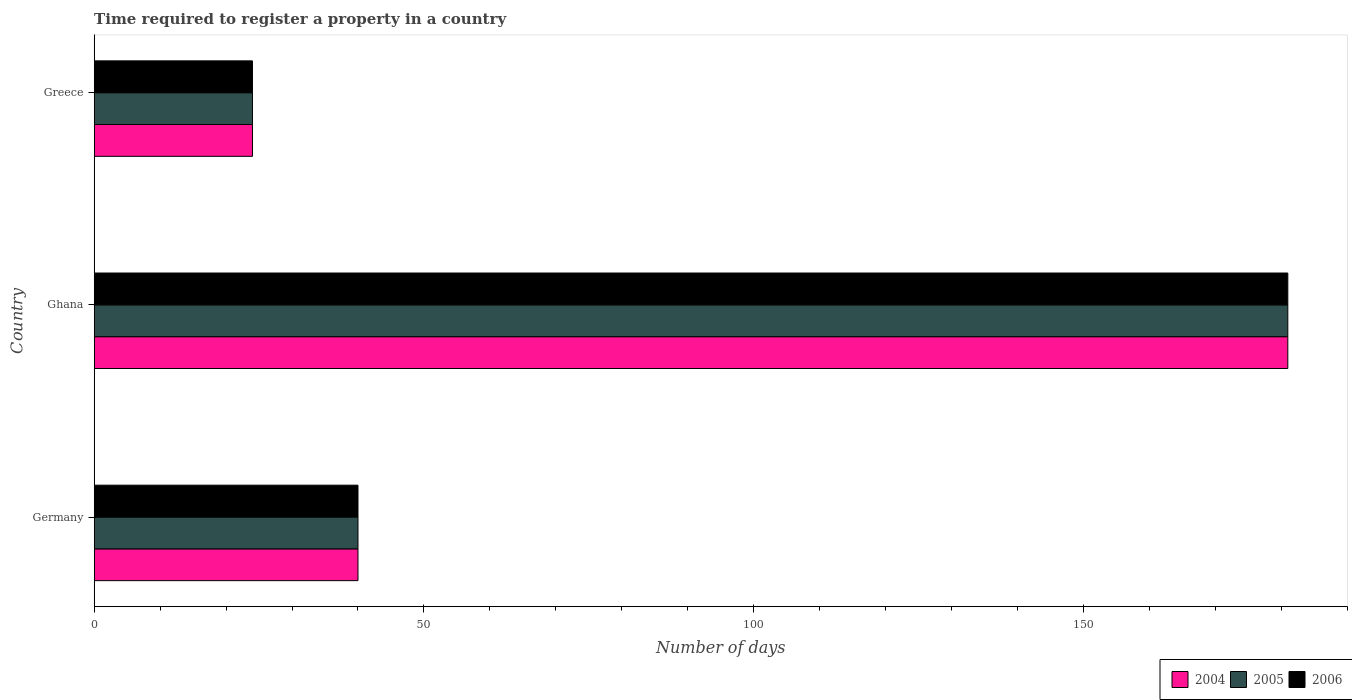How many groups of bars are there?
Your answer should be compact. 3. Are the number of bars per tick equal to the number of legend labels?
Your answer should be very brief. Yes. How many bars are there on the 1st tick from the top?
Your answer should be very brief. 3. What is the label of the 2nd group of bars from the top?
Give a very brief answer. Ghana. In how many cases, is the number of bars for a given country not equal to the number of legend labels?
Give a very brief answer. 0. Across all countries, what is the maximum number of days required to register a property in 2006?
Your answer should be very brief. 181. In which country was the number of days required to register a property in 2006 maximum?
Provide a succinct answer. Ghana. What is the total number of days required to register a property in 2005 in the graph?
Provide a short and direct response. 245. What is the difference between the number of days required to register a property in 2006 in Greece and the number of days required to register a property in 2005 in Ghana?
Keep it short and to the point. -157. What is the average number of days required to register a property in 2006 per country?
Ensure brevity in your answer.  81.67. In how many countries, is the number of days required to register a property in 2006 greater than 110 days?
Your answer should be very brief. 1. What is the ratio of the number of days required to register a property in 2005 in Germany to that in Greece?
Your response must be concise. 1.67. Is the number of days required to register a property in 2004 in Germany less than that in Ghana?
Provide a succinct answer. Yes. Is the difference between the number of days required to register a property in 2005 in Ghana and Greece greater than the difference between the number of days required to register a property in 2004 in Ghana and Greece?
Ensure brevity in your answer.  No. What is the difference between the highest and the second highest number of days required to register a property in 2005?
Provide a short and direct response. 141. What is the difference between the highest and the lowest number of days required to register a property in 2005?
Ensure brevity in your answer.  157. Is the sum of the number of days required to register a property in 2004 in Ghana and Greece greater than the maximum number of days required to register a property in 2005 across all countries?
Keep it short and to the point. Yes. What does the 3rd bar from the top in Germany represents?
Provide a short and direct response. 2004. What does the 1st bar from the bottom in Germany represents?
Make the answer very short. 2004. How many bars are there?
Give a very brief answer. 9. What is the difference between two consecutive major ticks on the X-axis?
Offer a very short reply. 50. Are the values on the major ticks of X-axis written in scientific E-notation?
Offer a terse response. No. Where does the legend appear in the graph?
Give a very brief answer. Bottom right. How are the legend labels stacked?
Your response must be concise. Horizontal. What is the title of the graph?
Provide a succinct answer. Time required to register a property in a country. Does "1986" appear as one of the legend labels in the graph?
Your answer should be compact. No. What is the label or title of the X-axis?
Your response must be concise. Number of days. What is the label or title of the Y-axis?
Offer a very short reply. Country. What is the Number of days in 2004 in Germany?
Make the answer very short. 40. What is the Number of days of 2005 in Germany?
Offer a terse response. 40. What is the Number of days in 2004 in Ghana?
Give a very brief answer. 181. What is the Number of days of 2005 in Ghana?
Your answer should be compact. 181. What is the Number of days of 2006 in Ghana?
Offer a very short reply. 181. What is the Number of days in 2005 in Greece?
Ensure brevity in your answer.  24. What is the Number of days in 2006 in Greece?
Your answer should be compact. 24. Across all countries, what is the maximum Number of days of 2004?
Provide a short and direct response. 181. Across all countries, what is the maximum Number of days in 2005?
Your answer should be very brief. 181. Across all countries, what is the maximum Number of days of 2006?
Offer a very short reply. 181. What is the total Number of days of 2004 in the graph?
Ensure brevity in your answer.  245. What is the total Number of days of 2005 in the graph?
Ensure brevity in your answer.  245. What is the total Number of days in 2006 in the graph?
Your answer should be compact. 245. What is the difference between the Number of days of 2004 in Germany and that in Ghana?
Your answer should be compact. -141. What is the difference between the Number of days of 2005 in Germany and that in Ghana?
Your answer should be compact. -141. What is the difference between the Number of days of 2006 in Germany and that in Ghana?
Your answer should be very brief. -141. What is the difference between the Number of days of 2005 in Germany and that in Greece?
Make the answer very short. 16. What is the difference between the Number of days of 2004 in Ghana and that in Greece?
Offer a very short reply. 157. What is the difference between the Number of days of 2005 in Ghana and that in Greece?
Your response must be concise. 157. What is the difference between the Number of days in 2006 in Ghana and that in Greece?
Provide a succinct answer. 157. What is the difference between the Number of days of 2004 in Germany and the Number of days of 2005 in Ghana?
Give a very brief answer. -141. What is the difference between the Number of days of 2004 in Germany and the Number of days of 2006 in Ghana?
Ensure brevity in your answer.  -141. What is the difference between the Number of days of 2005 in Germany and the Number of days of 2006 in Ghana?
Give a very brief answer. -141. What is the difference between the Number of days in 2004 in Ghana and the Number of days in 2005 in Greece?
Provide a short and direct response. 157. What is the difference between the Number of days of 2004 in Ghana and the Number of days of 2006 in Greece?
Provide a succinct answer. 157. What is the difference between the Number of days in 2005 in Ghana and the Number of days in 2006 in Greece?
Make the answer very short. 157. What is the average Number of days of 2004 per country?
Make the answer very short. 81.67. What is the average Number of days in 2005 per country?
Offer a very short reply. 81.67. What is the average Number of days of 2006 per country?
Your response must be concise. 81.67. What is the difference between the Number of days of 2004 and Number of days of 2006 in Germany?
Your answer should be very brief. 0. What is the difference between the Number of days in 2005 and Number of days in 2006 in Germany?
Provide a short and direct response. 0. What is the difference between the Number of days in 2004 and Number of days in 2006 in Ghana?
Keep it short and to the point. 0. What is the difference between the Number of days in 2004 and Number of days in 2005 in Greece?
Your response must be concise. 0. What is the difference between the Number of days of 2004 and Number of days of 2006 in Greece?
Keep it short and to the point. 0. What is the difference between the Number of days in 2005 and Number of days in 2006 in Greece?
Keep it short and to the point. 0. What is the ratio of the Number of days of 2004 in Germany to that in Ghana?
Keep it short and to the point. 0.22. What is the ratio of the Number of days in 2005 in Germany to that in Ghana?
Keep it short and to the point. 0.22. What is the ratio of the Number of days in 2006 in Germany to that in Ghana?
Your answer should be compact. 0.22. What is the ratio of the Number of days of 2005 in Germany to that in Greece?
Your response must be concise. 1.67. What is the ratio of the Number of days in 2004 in Ghana to that in Greece?
Your response must be concise. 7.54. What is the ratio of the Number of days in 2005 in Ghana to that in Greece?
Make the answer very short. 7.54. What is the ratio of the Number of days in 2006 in Ghana to that in Greece?
Offer a very short reply. 7.54. What is the difference between the highest and the second highest Number of days of 2004?
Ensure brevity in your answer.  141. What is the difference between the highest and the second highest Number of days in 2005?
Provide a succinct answer. 141. What is the difference between the highest and the second highest Number of days in 2006?
Provide a succinct answer. 141. What is the difference between the highest and the lowest Number of days in 2004?
Your response must be concise. 157. What is the difference between the highest and the lowest Number of days in 2005?
Provide a succinct answer. 157. What is the difference between the highest and the lowest Number of days in 2006?
Your response must be concise. 157. 